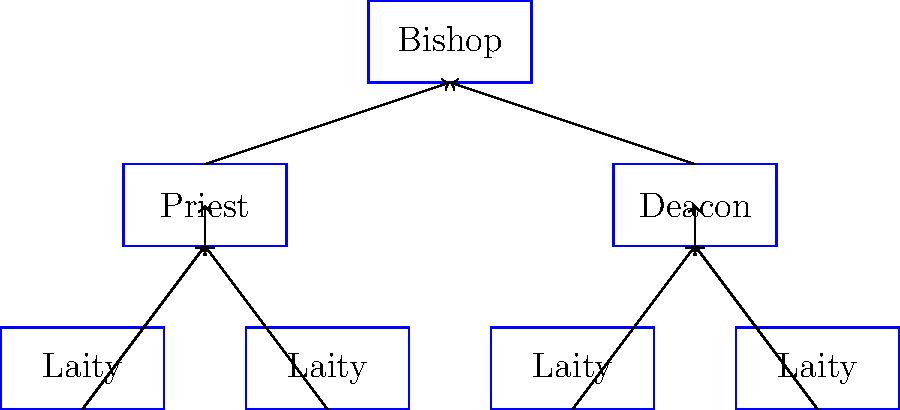Based on the organizational chart of church leadership shown above, which role serves as the primary link between the laity and the bishop, and why is this position crucial for the functioning of the church hierarchy? To answer this question, let's analyze the organizational chart step-by-step:

1. The chart shows a hierarchical structure with four levels:
   - Bishop at the top
   - Priest and Deacon in the middle
   - Laity at the bottom

2. The arrows indicate the direction of authority and communication flow:
   - Laity members report to both Priests and Deacons
   - Priests and Deacons report to the Bishop

3. The Priest position is shown on the left side of the chart, directly connected to both the Laity and the Bishop.

4. The Deacon position is shown on the right side, also connected to both the Laity and the Bishop.

5. However, the Priest position is traditionally considered the primary link between the Laity and the Bishop for several reasons:
   a. Priests are typically responsible for leading congregations and parishes
   b. They perform most sacraments and rituals
   c. They often have more direct and frequent contact with the Laity

6. The Priest's role is crucial for the functioning of the church hierarchy because:
   a. They interpret and communicate the Bishop's teachings to the Laity
   b. They provide pastoral care and guidance to the congregation
   c. They relay the needs and concerns of the Laity back to the Bishop
   d. They help maintain the unity and cohesion of the church community

7. While Deacons also play an important role in serving the church and connecting with the Laity, their responsibilities are generally more focused on specific areas of service rather than overall leadership of a congregation.

Therefore, the Priest serves as the primary link between the Laity and the Bishop, acting as a crucial intermediary in the church hierarchy.
Answer: Priest; intermediary between Laity and Bishop, providing leadership, sacraments, and communication. 